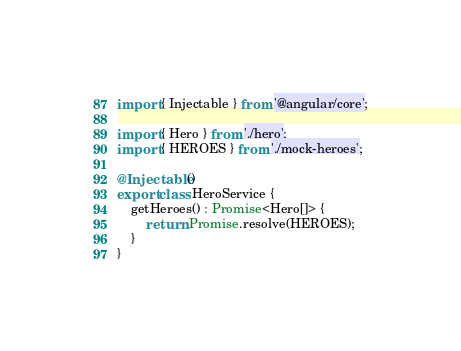<code> <loc_0><loc_0><loc_500><loc_500><_TypeScript_>import { Injectable } from '@angular/core';

import { Hero } from './hero';
import { HEROES } from './mock-heroes';

@Injectable()
export class HeroService {
    getHeroes() : Promise<Hero[]> {
        return Promise.resolve(HEROES);
    }
}
</code> 